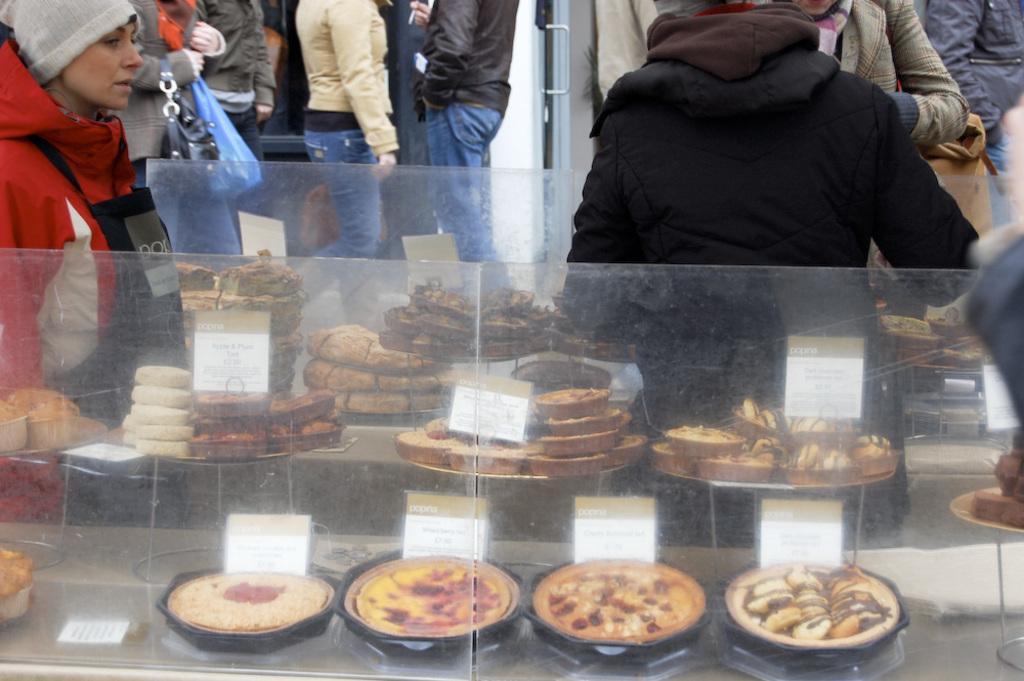In one or two sentences, can you explain what this image depicts? In this picture we can see some people standing here, this person is carrying a bag, we can see a rack here, we can see some pizzas present here, there is some food here, we can see price tags 